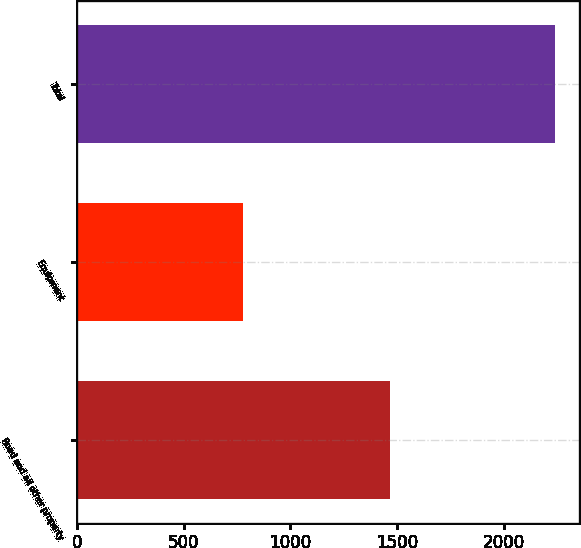Convert chart to OTSL. <chart><loc_0><loc_0><loc_500><loc_500><bar_chart><fcel>Road and all other property<fcel>Equipment<fcel>Total<nl><fcel>1465<fcel>776<fcel>2241<nl></chart> 